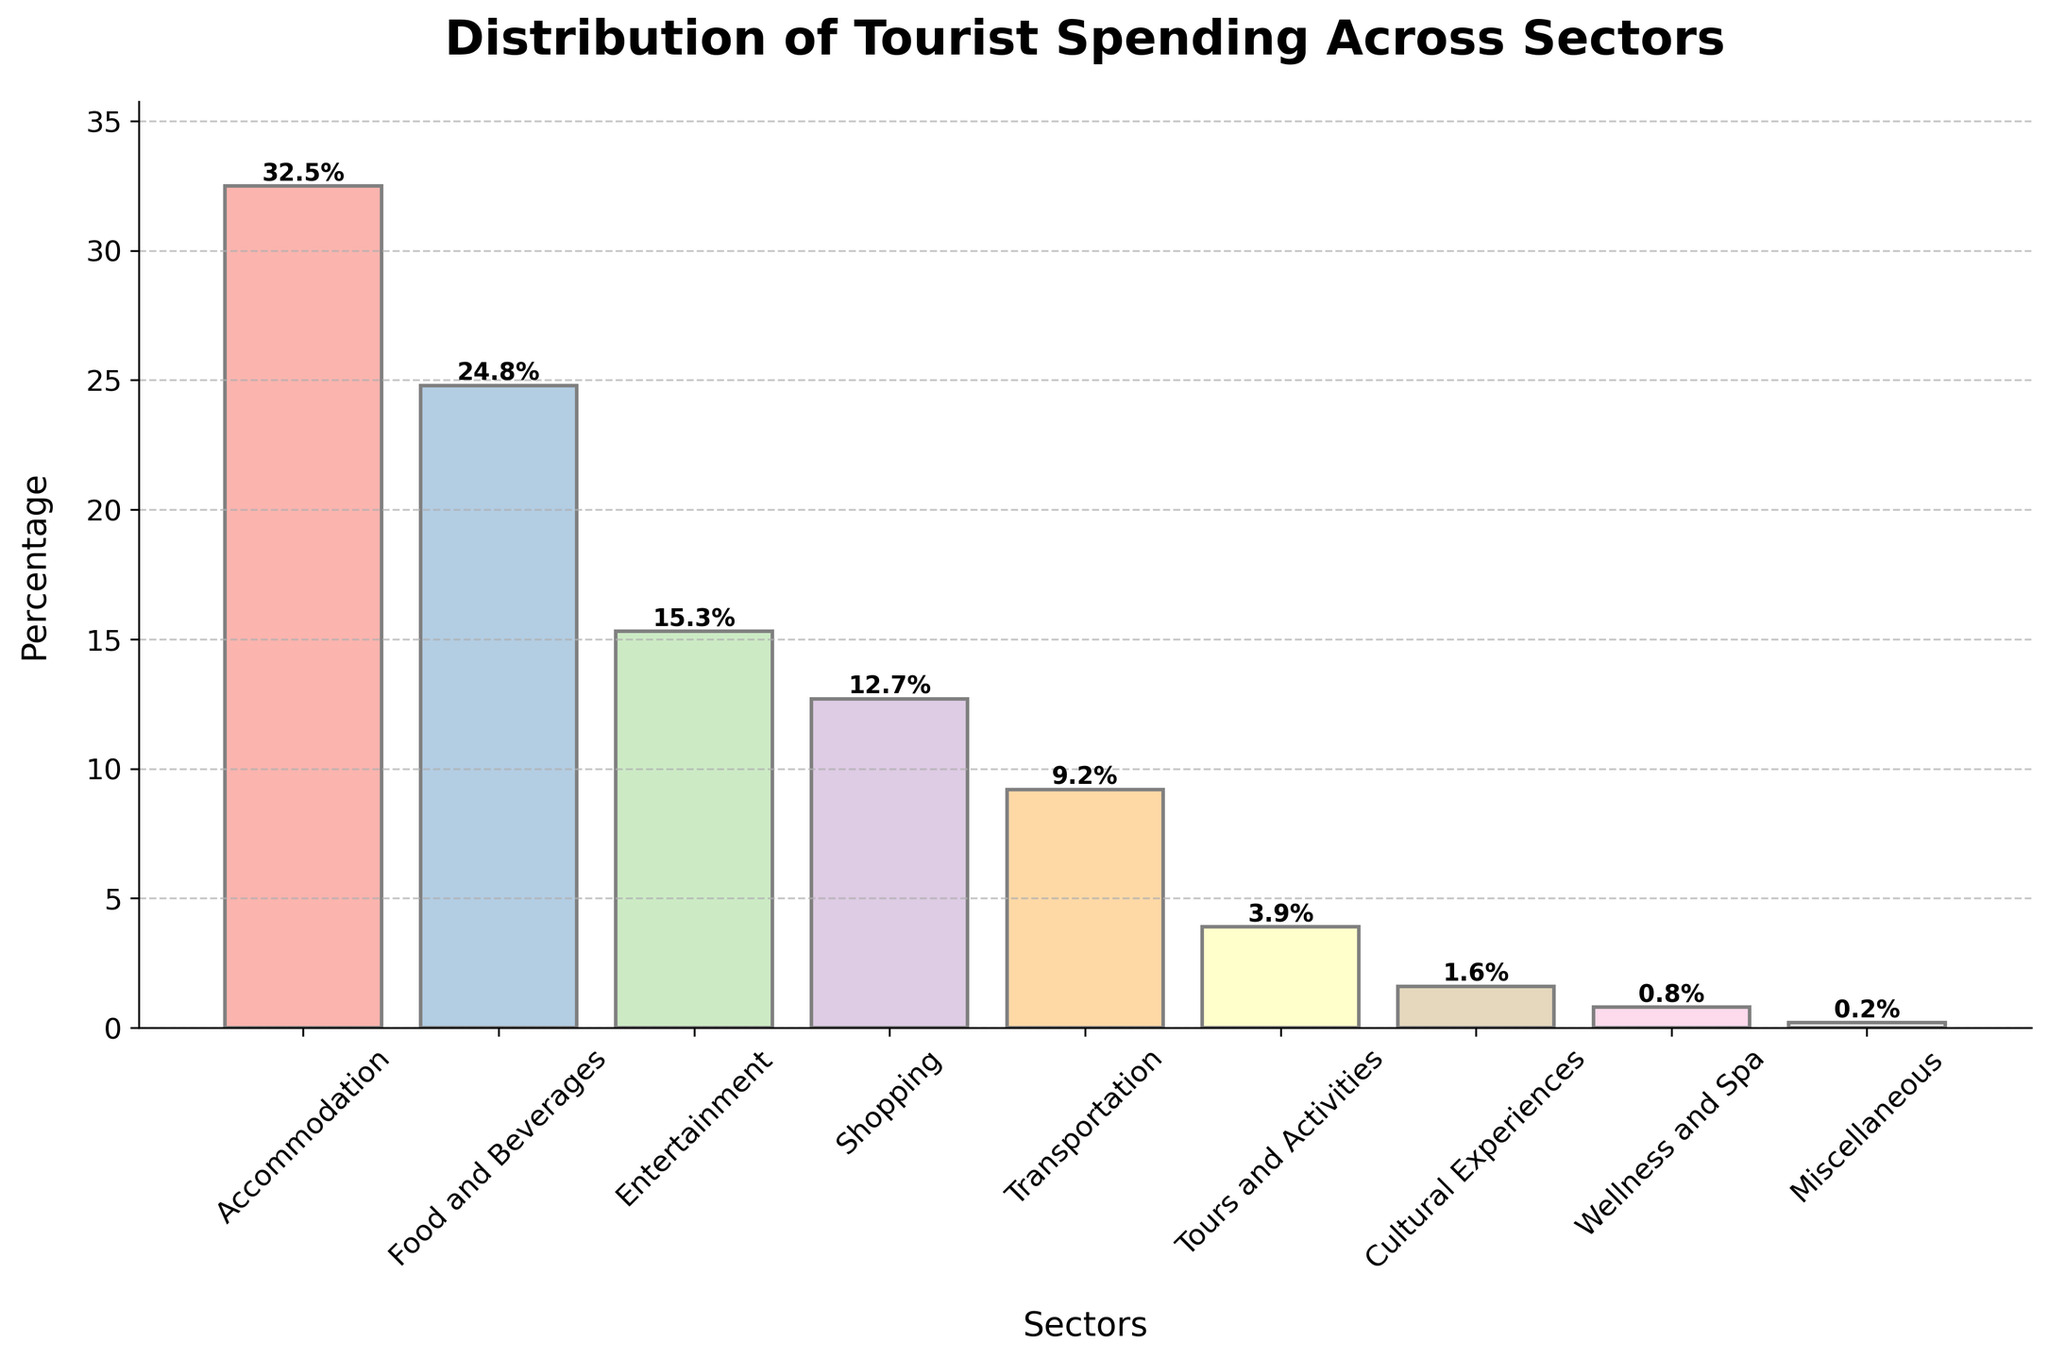What percentage of tourist spending goes to accommodation and food and beverages combined? To find this, add the percentages of tourist spending for accommodation (32.5%) and food and beverages (24.8%). The combined percentage is 32.5% + 24.8% = 57.3%.
Answer: 57.3% Which sector has the lowest percentage of tourist spending? The sector with the lowest percentage is the one with the smallest bar. According to the data, Miscellaneous has the lowest percentage at 0.2%.
Answer: Miscellaneous How much more is spent on accommodation compared to tours and activities? Subtract the percentage of spending on tours and activities (3.9%) from the percentage of spending on accommodation (32.5%). The difference is 32.5% - 3.9% = 28.6%.
Answer: 28.6% Is more spent on transportation or shopping? Compare the height of the bars for transportation (9.2%) and shopping (12.7%). Since the shopping bar is taller, more is spent on shopping.
Answer: Shopping What is the total percentage of tourist spending on entertainment, shopping, and transportation combined? Add the percentages of tourist spending for entertainment (15.3%), shopping (12.7%), and transportation (9.2%). The total percentage is 15.3% + 12.7% + 9.2% = 37.2%.
Answer: 37.2% Are food and beverages spending and entertainment spending equal? Compare the percentages of food and beverages (24.8%) and entertainment (15.3%). The percentages are not equal as 24.8% is larger than 15.3%.
Answer: No What is the difference in percentage between the highest and the lowest spending sectors? Subtract the percentage of the lowest spending sector (Miscellaneous, 0.2%) from the highest spending sector (Accommodation, 32.5%). The difference is 32.5% - 0.2% = 32.3%.
Answer: 32.3% Which sector has the second highest spending? Identify the sector with the second tallest bar, which is food and beverages at 24.8%.
Answer: Food and Beverages What is the average percentage of spending across all sectors? To find the average, sum up all the percentages and divide by the number of sectors. (32.5 + 24.8 + 15.3 + 12.7 + 9.2 + 3.9 + 1.6 + 0.8 + 0.2) = 101.0%. Dividing by 9 sectors, the average is approximately 11.22%.
Answer: 11.22% 